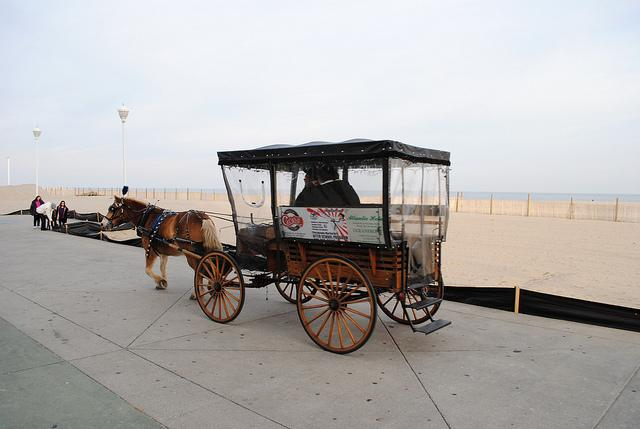What is near the sidewalk here?

Choices:
A) beach
B) grocery store
C) cow fields
D) dairy beach 